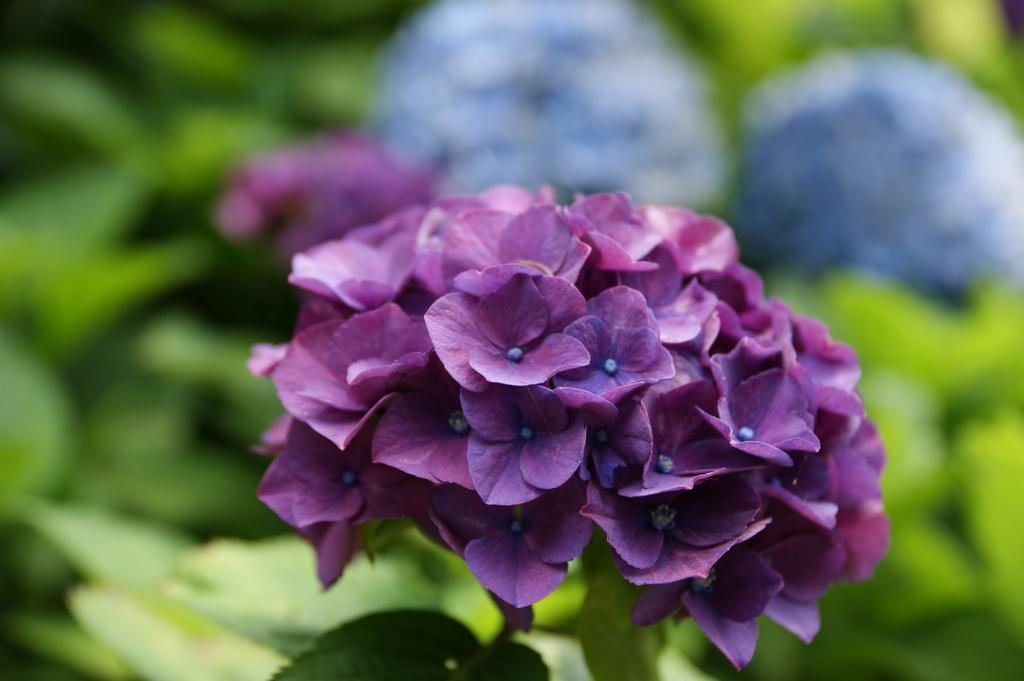What color are the flowers on the plants in the image? There are violet flowers and blue flowers on the plants in the image. Can you describe the appearance of the plants in the image? Unfortunately, the provided facts do not mention any details about the appearance of the plants, only the colors of the flowers. What type of bread is being used to cause the flowers to grow in the image? There is no bread or indication of a cause for the flowers' growth in the image. 